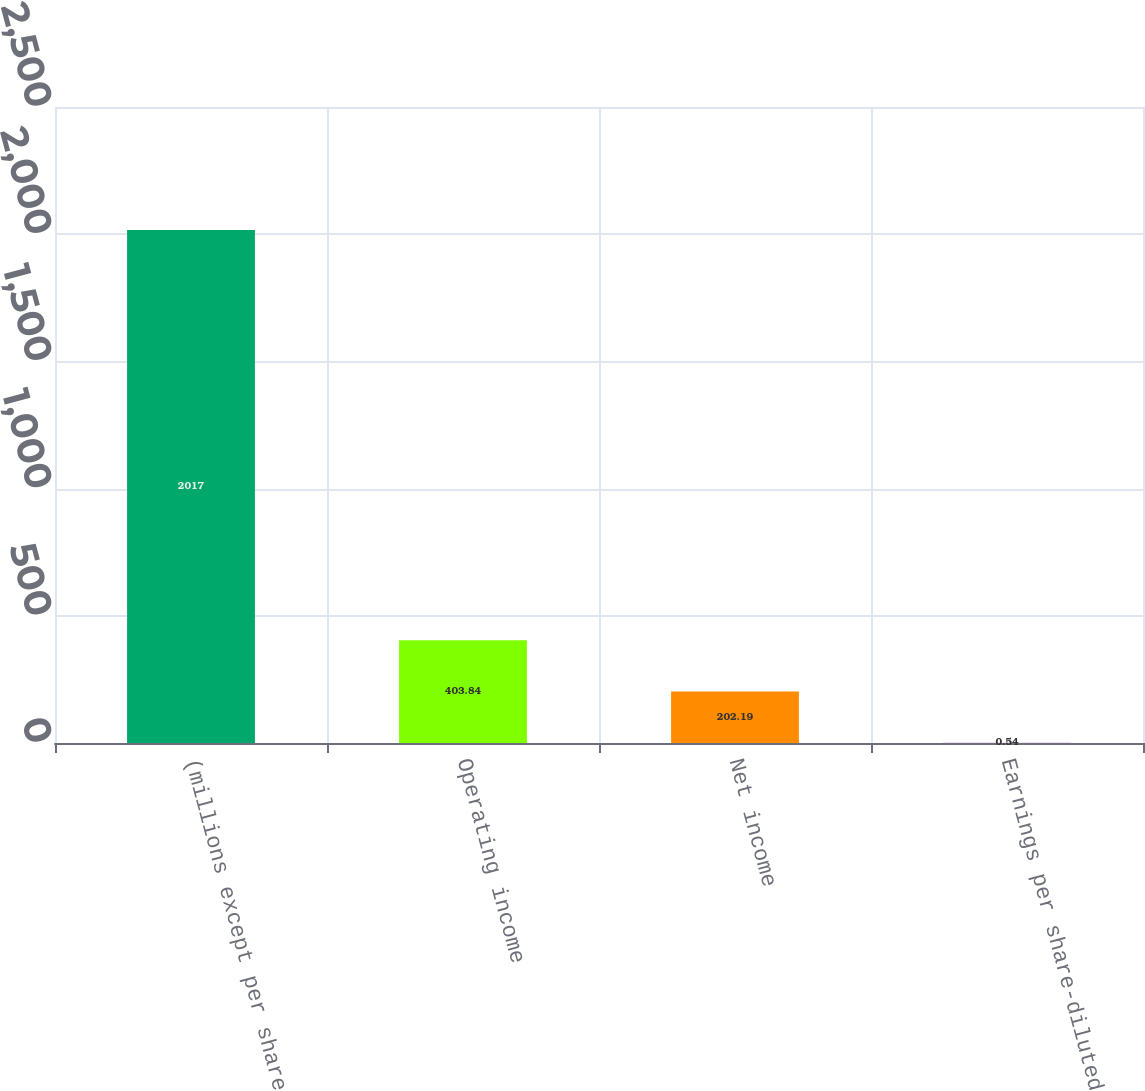<chart> <loc_0><loc_0><loc_500><loc_500><bar_chart><fcel>(millions except per share<fcel>Operating income<fcel>Net income<fcel>Earnings per share-diluted<nl><fcel>2017<fcel>403.84<fcel>202.19<fcel>0.54<nl></chart> 